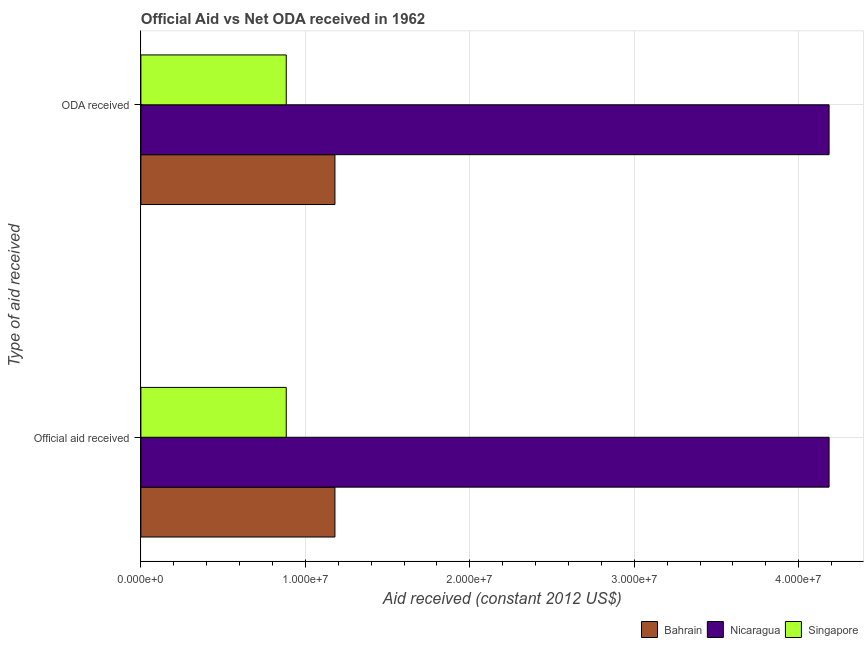What is the label of the 2nd group of bars from the top?
Keep it short and to the point. Official aid received. What is the oda received in Nicaragua?
Offer a terse response. 4.18e+07. Across all countries, what is the maximum official aid received?
Offer a terse response. 4.18e+07. Across all countries, what is the minimum oda received?
Your answer should be very brief. 8.84e+06. In which country was the official aid received maximum?
Your answer should be compact. Nicaragua. In which country was the oda received minimum?
Provide a short and direct response. Singapore. What is the total oda received in the graph?
Offer a terse response. 6.25e+07. What is the difference between the oda received in Singapore and that in Nicaragua?
Offer a terse response. -3.30e+07. What is the difference between the official aid received in Nicaragua and the oda received in Bahrain?
Your response must be concise. 3.00e+07. What is the average official aid received per country?
Give a very brief answer. 2.08e+07. What is the difference between the oda received and official aid received in Singapore?
Make the answer very short. 0. In how many countries, is the official aid received greater than 30000000 US$?
Keep it short and to the point. 1. What is the ratio of the oda received in Singapore to that in Nicaragua?
Offer a terse response. 0.21. Is the official aid received in Singapore less than that in Bahrain?
Your response must be concise. Yes. What does the 3rd bar from the top in ODA received represents?
Give a very brief answer. Bahrain. What does the 2nd bar from the bottom in Official aid received represents?
Keep it short and to the point. Nicaragua. Are all the bars in the graph horizontal?
Keep it short and to the point. Yes. How many countries are there in the graph?
Keep it short and to the point. 3. What is the difference between two consecutive major ticks on the X-axis?
Your response must be concise. 1.00e+07. Where does the legend appear in the graph?
Provide a succinct answer. Bottom right. What is the title of the graph?
Make the answer very short. Official Aid vs Net ODA received in 1962 . Does "Tonga" appear as one of the legend labels in the graph?
Make the answer very short. No. What is the label or title of the X-axis?
Your response must be concise. Aid received (constant 2012 US$). What is the label or title of the Y-axis?
Offer a very short reply. Type of aid received. What is the Aid received (constant 2012 US$) in Bahrain in Official aid received?
Provide a succinct answer. 1.18e+07. What is the Aid received (constant 2012 US$) of Nicaragua in Official aid received?
Offer a very short reply. 4.18e+07. What is the Aid received (constant 2012 US$) in Singapore in Official aid received?
Offer a terse response. 8.84e+06. What is the Aid received (constant 2012 US$) of Bahrain in ODA received?
Offer a very short reply. 1.18e+07. What is the Aid received (constant 2012 US$) in Nicaragua in ODA received?
Provide a short and direct response. 4.18e+07. What is the Aid received (constant 2012 US$) in Singapore in ODA received?
Provide a short and direct response. 8.84e+06. Across all Type of aid received, what is the maximum Aid received (constant 2012 US$) in Bahrain?
Your response must be concise. 1.18e+07. Across all Type of aid received, what is the maximum Aid received (constant 2012 US$) of Nicaragua?
Offer a very short reply. 4.18e+07. Across all Type of aid received, what is the maximum Aid received (constant 2012 US$) in Singapore?
Offer a terse response. 8.84e+06. Across all Type of aid received, what is the minimum Aid received (constant 2012 US$) in Bahrain?
Provide a succinct answer. 1.18e+07. Across all Type of aid received, what is the minimum Aid received (constant 2012 US$) of Nicaragua?
Provide a succinct answer. 4.18e+07. Across all Type of aid received, what is the minimum Aid received (constant 2012 US$) in Singapore?
Offer a very short reply. 8.84e+06. What is the total Aid received (constant 2012 US$) of Bahrain in the graph?
Give a very brief answer. 2.36e+07. What is the total Aid received (constant 2012 US$) of Nicaragua in the graph?
Your answer should be very brief. 8.37e+07. What is the total Aid received (constant 2012 US$) in Singapore in the graph?
Your answer should be compact. 1.77e+07. What is the difference between the Aid received (constant 2012 US$) of Singapore in Official aid received and that in ODA received?
Your response must be concise. 0. What is the difference between the Aid received (constant 2012 US$) in Bahrain in Official aid received and the Aid received (constant 2012 US$) in Nicaragua in ODA received?
Your answer should be compact. -3.00e+07. What is the difference between the Aid received (constant 2012 US$) of Bahrain in Official aid received and the Aid received (constant 2012 US$) of Singapore in ODA received?
Your response must be concise. 2.96e+06. What is the difference between the Aid received (constant 2012 US$) in Nicaragua in Official aid received and the Aid received (constant 2012 US$) in Singapore in ODA received?
Give a very brief answer. 3.30e+07. What is the average Aid received (constant 2012 US$) in Bahrain per Type of aid received?
Offer a very short reply. 1.18e+07. What is the average Aid received (constant 2012 US$) in Nicaragua per Type of aid received?
Provide a succinct answer. 4.18e+07. What is the average Aid received (constant 2012 US$) of Singapore per Type of aid received?
Offer a very short reply. 8.84e+06. What is the difference between the Aid received (constant 2012 US$) of Bahrain and Aid received (constant 2012 US$) of Nicaragua in Official aid received?
Ensure brevity in your answer.  -3.00e+07. What is the difference between the Aid received (constant 2012 US$) of Bahrain and Aid received (constant 2012 US$) of Singapore in Official aid received?
Ensure brevity in your answer.  2.96e+06. What is the difference between the Aid received (constant 2012 US$) in Nicaragua and Aid received (constant 2012 US$) in Singapore in Official aid received?
Your answer should be very brief. 3.30e+07. What is the difference between the Aid received (constant 2012 US$) in Bahrain and Aid received (constant 2012 US$) in Nicaragua in ODA received?
Provide a succinct answer. -3.00e+07. What is the difference between the Aid received (constant 2012 US$) in Bahrain and Aid received (constant 2012 US$) in Singapore in ODA received?
Provide a succinct answer. 2.96e+06. What is the difference between the Aid received (constant 2012 US$) of Nicaragua and Aid received (constant 2012 US$) of Singapore in ODA received?
Give a very brief answer. 3.30e+07. What is the ratio of the Aid received (constant 2012 US$) in Bahrain in Official aid received to that in ODA received?
Ensure brevity in your answer.  1. What is the difference between the highest and the lowest Aid received (constant 2012 US$) in Singapore?
Provide a succinct answer. 0. 